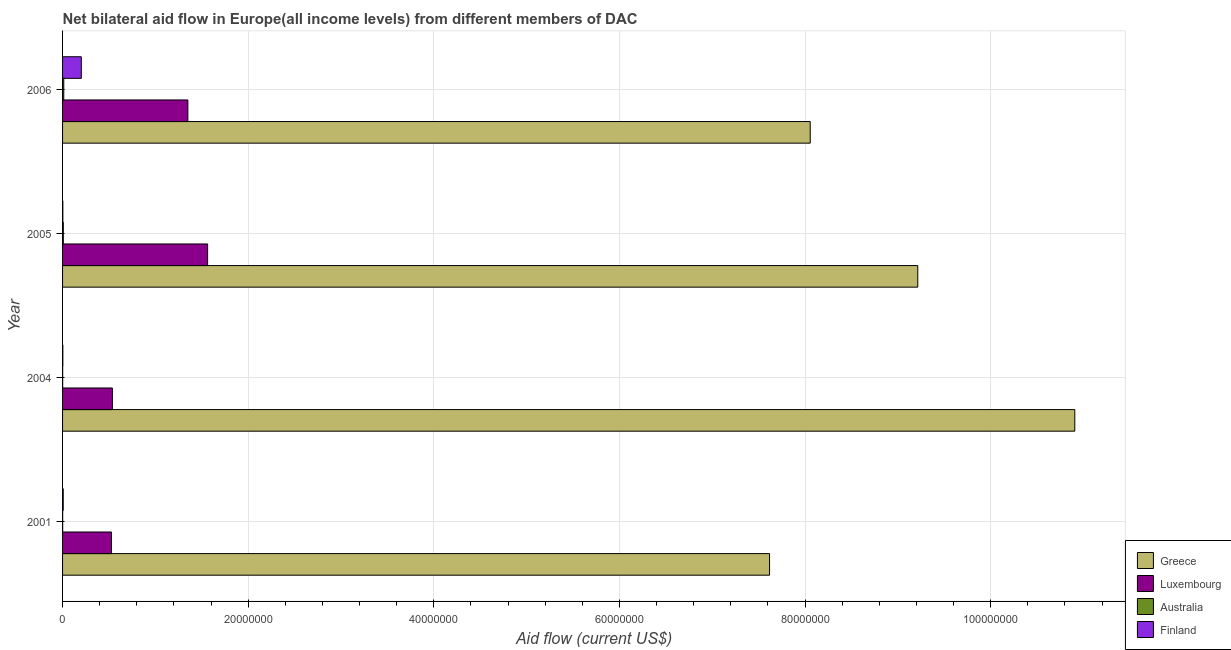How many different coloured bars are there?
Your answer should be very brief. 4. Are the number of bars per tick equal to the number of legend labels?
Your response must be concise. Yes. How many bars are there on the 3rd tick from the top?
Your answer should be compact. 4. How many bars are there on the 3rd tick from the bottom?
Make the answer very short. 4. What is the label of the 3rd group of bars from the top?
Make the answer very short. 2004. What is the amount of aid given by luxembourg in 2005?
Provide a succinct answer. 1.56e+07. Across all years, what is the maximum amount of aid given by greece?
Keep it short and to the point. 1.09e+08. Across all years, what is the minimum amount of aid given by finland?
Ensure brevity in your answer.  3.00e+04. What is the total amount of aid given by luxembourg in the graph?
Provide a succinct answer. 3.98e+07. What is the difference between the amount of aid given by greece in 2001 and that in 2005?
Give a very brief answer. -1.60e+07. What is the difference between the amount of aid given by australia in 2005 and the amount of aid given by luxembourg in 2006?
Ensure brevity in your answer.  -1.34e+07. What is the average amount of aid given by australia per year?
Offer a very short reply. 5.75e+04. In the year 2006, what is the difference between the amount of aid given by greece and amount of aid given by luxembourg?
Your answer should be compact. 6.71e+07. In how many years, is the amount of aid given by australia greater than 68000000 US$?
Provide a short and direct response. 0. What is the ratio of the amount of aid given by australia in 2004 to that in 2006?
Your response must be concise. 0.08. What is the difference between the highest and the second highest amount of aid given by finland?
Your answer should be very brief. 1.95e+06. What is the difference between the highest and the lowest amount of aid given by finland?
Offer a terse response. 1.99e+06. Is the sum of the amount of aid given by australia in 2001 and 2004 greater than the maximum amount of aid given by greece across all years?
Make the answer very short. No. Is it the case that in every year, the sum of the amount of aid given by finland and amount of aid given by australia is greater than the sum of amount of aid given by greece and amount of aid given by luxembourg?
Make the answer very short. No. What does the 1st bar from the top in 2005 represents?
Your response must be concise. Finland. What does the 4th bar from the bottom in 2005 represents?
Make the answer very short. Finland. Is it the case that in every year, the sum of the amount of aid given by greece and amount of aid given by luxembourg is greater than the amount of aid given by australia?
Provide a short and direct response. Yes. How many years are there in the graph?
Offer a terse response. 4. Are the values on the major ticks of X-axis written in scientific E-notation?
Keep it short and to the point. No. Does the graph contain any zero values?
Your response must be concise. No. How many legend labels are there?
Keep it short and to the point. 4. How are the legend labels stacked?
Your response must be concise. Vertical. What is the title of the graph?
Provide a succinct answer. Net bilateral aid flow in Europe(all income levels) from different members of DAC. What is the label or title of the X-axis?
Offer a terse response. Aid flow (current US$). What is the label or title of the Y-axis?
Offer a terse response. Year. What is the Aid flow (current US$) of Greece in 2001?
Offer a terse response. 7.62e+07. What is the Aid flow (current US$) of Luxembourg in 2001?
Your answer should be compact. 5.27e+06. What is the Aid flow (current US$) in Finland in 2001?
Provide a succinct answer. 7.00e+04. What is the Aid flow (current US$) of Greece in 2004?
Make the answer very short. 1.09e+08. What is the Aid flow (current US$) of Luxembourg in 2004?
Keep it short and to the point. 5.37e+06. What is the Aid flow (current US$) of Finland in 2004?
Offer a very short reply. 3.00e+04. What is the Aid flow (current US$) in Greece in 2005?
Your answer should be compact. 9.22e+07. What is the Aid flow (current US$) of Luxembourg in 2005?
Keep it short and to the point. 1.56e+07. What is the Aid flow (current US$) of Australia in 2005?
Your answer should be very brief. 8.00e+04. What is the Aid flow (current US$) in Finland in 2005?
Offer a terse response. 3.00e+04. What is the Aid flow (current US$) of Greece in 2006?
Your response must be concise. 8.06e+07. What is the Aid flow (current US$) of Luxembourg in 2006?
Offer a very short reply. 1.35e+07. What is the Aid flow (current US$) in Finland in 2006?
Offer a terse response. 2.02e+06. Across all years, what is the maximum Aid flow (current US$) in Greece?
Give a very brief answer. 1.09e+08. Across all years, what is the maximum Aid flow (current US$) of Luxembourg?
Make the answer very short. 1.56e+07. Across all years, what is the maximum Aid flow (current US$) in Australia?
Give a very brief answer. 1.30e+05. Across all years, what is the maximum Aid flow (current US$) in Finland?
Provide a short and direct response. 2.02e+06. Across all years, what is the minimum Aid flow (current US$) of Greece?
Offer a terse response. 7.62e+07. Across all years, what is the minimum Aid flow (current US$) of Luxembourg?
Provide a short and direct response. 5.27e+06. What is the total Aid flow (current US$) in Greece in the graph?
Your answer should be compact. 3.58e+08. What is the total Aid flow (current US$) of Luxembourg in the graph?
Your answer should be compact. 3.98e+07. What is the total Aid flow (current US$) of Australia in the graph?
Give a very brief answer. 2.30e+05. What is the total Aid flow (current US$) of Finland in the graph?
Provide a short and direct response. 2.15e+06. What is the difference between the Aid flow (current US$) in Greece in 2001 and that in 2004?
Keep it short and to the point. -3.29e+07. What is the difference between the Aid flow (current US$) in Luxembourg in 2001 and that in 2004?
Provide a short and direct response. -1.00e+05. What is the difference between the Aid flow (current US$) in Finland in 2001 and that in 2004?
Provide a succinct answer. 4.00e+04. What is the difference between the Aid flow (current US$) in Greece in 2001 and that in 2005?
Your answer should be very brief. -1.60e+07. What is the difference between the Aid flow (current US$) of Luxembourg in 2001 and that in 2005?
Offer a terse response. -1.04e+07. What is the difference between the Aid flow (current US$) in Australia in 2001 and that in 2005?
Keep it short and to the point. -7.00e+04. What is the difference between the Aid flow (current US$) in Finland in 2001 and that in 2005?
Your answer should be very brief. 4.00e+04. What is the difference between the Aid flow (current US$) in Greece in 2001 and that in 2006?
Offer a very short reply. -4.38e+06. What is the difference between the Aid flow (current US$) of Luxembourg in 2001 and that in 2006?
Give a very brief answer. -8.23e+06. What is the difference between the Aid flow (current US$) of Australia in 2001 and that in 2006?
Offer a very short reply. -1.20e+05. What is the difference between the Aid flow (current US$) in Finland in 2001 and that in 2006?
Keep it short and to the point. -1.95e+06. What is the difference between the Aid flow (current US$) of Greece in 2004 and that in 2005?
Offer a terse response. 1.69e+07. What is the difference between the Aid flow (current US$) in Luxembourg in 2004 and that in 2005?
Ensure brevity in your answer.  -1.03e+07. What is the difference between the Aid flow (current US$) of Australia in 2004 and that in 2005?
Offer a very short reply. -7.00e+04. What is the difference between the Aid flow (current US$) of Greece in 2004 and that in 2006?
Your answer should be compact. 2.85e+07. What is the difference between the Aid flow (current US$) of Luxembourg in 2004 and that in 2006?
Keep it short and to the point. -8.13e+06. What is the difference between the Aid flow (current US$) of Australia in 2004 and that in 2006?
Give a very brief answer. -1.20e+05. What is the difference between the Aid flow (current US$) of Finland in 2004 and that in 2006?
Provide a succinct answer. -1.99e+06. What is the difference between the Aid flow (current US$) of Greece in 2005 and that in 2006?
Your answer should be compact. 1.16e+07. What is the difference between the Aid flow (current US$) of Luxembourg in 2005 and that in 2006?
Keep it short and to the point. 2.13e+06. What is the difference between the Aid flow (current US$) of Australia in 2005 and that in 2006?
Offer a terse response. -5.00e+04. What is the difference between the Aid flow (current US$) in Finland in 2005 and that in 2006?
Give a very brief answer. -1.99e+06. What is the difference between the Aid flow (current US$) of Greece in 2001 and the Aid flow (current US$) of Luxembourg in 2004?
Give a very brief answer. 7.08e+07. What is the difference between the Aid flow (current US$) of Greece in 2001 and the Aid flow (current US$) of Australia in 2004?
Ensure brevity in your answer.  7.62e+07. What is the difference between the Aid flow (current US$) in Greece in 2001 and the Aid flow (current US$) in Finland in 2004?
Your answer should be compact. 7.62e+07. What is the difference between the Aid flow (current US$) in Luxembourg in 2001 and the Aid flow (current US$) in Australia in 2004?
Your response must be concise. 5.26e+06. What is the difference between the Aid flow (current US$) of Luxembourg in 2001 and the Aid flow (current US$) of Finland in 2004?
Offer a terse response. 5.24e+06. What is the difference between the Aid flow (current US$) in Greece in 2001 and the Aid flow (current US$) in Luxembourg in 2005?
Offer a terse response. 6.06e+07. What is the difference between the Aid flow (current US$) in Greece in 2001 and the Aid flow (current US$) in Australia in 2005?
Offer a terse response. 7.61e+07. What is the difference between the Aid flow (current US$) of Greece in 2001 and the Aid flow (current US$) of Finland in 2005?
Give a very brief answer. 7.62e+07. What is the difference between the Aid flow (current US$) in Luxembourg in 2001 and the Aid flow (current US$) in Australia in 2005?
Your response must be concise. 5.19e+06. What is the difference between the Aid flow (current US$) in Luxembourg in 2001 and the Aid flow (current US$) in Finland in 2005?
Your response must be concise. 5.24e+06. What is the difference between the Aid flow (current US$) of Australia in 2001 and the Aid flow (current US$) of Finland in 2005?
Your answer should be compact. -2.00e+04. What is the difference between the Aid flow (current US$) of Greece in 2001 and the Aid flow (current US$) of Luxembourg in 2006?
Your answer should be compact. 6.27e+07. What is the difference between the Aid flow (current US$) in Greece in 2001 and the Aid flow (current US$) in Australia in 2006?
Provide a short and direct response. 7.60e+07. What is the difference between the Aid flow (current US$) in Greece in 2001 and the Aid flow (current US$) in Finland in 2006?
Your response must be concise. 7.42e+07. What is the difference between the Aid flow (current US$) of Luxembourg in 2001 and the Aid flow (current US$) of Australia in 2006?
Your response must be concise. 5.14e+06. What is the difference between the Aid flow (current US$) of Luxembourg in 2001 and the Aid flow (current US$) of Finland in 2006?
Your response must be concise. 3.25e+06. What is the difference between the Aid flow (current US$) of Australia in 2001 and the Aid flow (current US$) of Finland in 2006?
Make the answer very short. -2.01e+06. What is the difference between the Aid flow (current US$) in Greece in 2004 and the Aid flow (current US$) in Luxembourg in 2005?
Your answer should be very brief. 9.34e+07. What is the difference between the Aid flow (current US$) in Greece in 2004 and the Aid flow (current US$) in Australia in 2005?
Provide a short and direct response. 1.09e+08. What is the difference between the Aid flow (current US$) in Greece in 2004 and the Aid flow (current US$) in Finland in 2005?
Make the answer very short. 1.09e+08. What is the difference between the Aid flow (current US$) of Luxembourg in 2004 and the Aid flow (current US$) of Australia in 2005?
Give a very brief answer. 5.29e+06. What is the difference between the Aid flow (current US$) of Luxembourg in 2004 and the Aid flow (current US$) of Finland in 2005?
Offer a very short reply. 5.34e+06. What is the difference between the Aid flow (current US$) in Australia in 2004 and the Aid flow (current US$) in Finland in 2005?
Your answer should be compact. -2.00e+04. What is the difference between the Aid flow (current US$) in Greece in 2004 and the Aid flow (current US$) in Luxembourg in 2006?
Your answer should be very brief. 9.56e+07. What is the difference between the Aid flow (current US$) in Greece in 2004 and the Aid flow (current US$) in Australia in 2006?
Your answer should be very brief. 1.09e+08. What is the difference between the Aid flow (current US$) in Greece in 2004 and the Aid flow (current US$) in Finland in 2006?
Keep it short and to the point. 1.07e+08. What is the difference between the Aid flow (current US$) in Luxembourg in 2004 and the Aid flow (current US$) in Australia in 2006?
Provide a short and direct response. 5.24e+06. What is the difference between the Aid flow (current US$) of Luxembourg in 2004 and the Aid flow (current US$) of Finland in 2006?
Offer a very short reply. 3.35e+06. What is the difference between the Aid flow (current US$) of Australia in 2004 and the Aid flow (current US$) of Finland in 2006?
Provide a short and direct response. -2.01e+06. What is the difference between the Aid flow (current US$) in Greece in 2005 and the Aid flow (current US$) in Luxembourg in 2006?
Give a very brief answer. 7.86e+07. What is the difference between the Aid flow (current US$) of Greece in 2005 and the Aid flow (current US$) of Australia in 2006?
Ensure brevity in your answer.  9.20e+07. What is the difference between the Aid flow (current US$) in Greece in 2005 and the Aid flow (current US$) in Finland in 2006?
Provide a short and direct response. 9.01e+07. What is the difference between the Aid flow (current US$) of Luxembourg in 2005 and the Aid flow (current US$) of Australia in 2006?
Make the answer very short. 1.55e+07. What is the difference between the Aid flow (current US$) of Luxembourg in 2005 and the Aid flow (current US$) of Finland in 2006?
Your answer should be very brief. 1.36e+07. What is the difference between the Aid flow (current US$) of Australia in 2005 and the Aid flow (current US$) of Finland in 2006?
Provide a succinct answer. -1.94e+06. What is the average Aid flow (current US$) of Greece per year?
Keep it short and to the point. 8.95e+07. What is the average Aid flow (current US$) of Luxembourg per year?
Your answer should be compact. 9.94e+06. What is the average Aid flow (current US$) of Australia per year?
Keep it short and to the point. 5.75e+04. What is the average Aid flow (current US$) in Finland per year?
Keep it short and to the point. 5.38e+05. In the year 2001, what is the difference between the Aid flow (current US$) in Greece and Aid flow (current US$) in Luxembourg?
Ensure brevity in your answer.  7.09e+07. In the year 2001, what is the difference between the Aid flow (current US$) in Greece and Aid flow (current US$) in Australia?
Keep it short and to the point. 7.62e+07. In the year 2001, what is the difference between the Aid flow (current US$) in Greece and Aid flow (current US$) in Finland?
Ensure brevity in your answer.  7.61e+07. In the year 2001, what is the difference between the Aid flow (current US$) of Luxembourg and Aid flow (current US$) of Australia?
Your answer should be very brief. 5.26e+06. In the year 2001, what is the difference between the Aid flow (current US$) in Luxembourg and Aid flow (current US$) in Finland?
Keep it short and to the point. 5.20e+06. In the year 2004, what is the difference between the Aid flow (current US$) in Greece and Aid flow (current US$) in Luxembourg?
Offer a terse response. 1.04e+08. In the year 2004, what is the difference between the Aid flow (current US$) of Greece and Aid flow (current US$) of Australia?
Your answer should be very brief. 1.09e+08. In the year 2004, what is the difference between the Aid flow (current US$) of Greece and Aid flow (current US$) of Finland?
Your response must be concise. 1.09e+08. In the year 2004, what is the difference between the Aid flow (current US$) of Luxembourg and Aid flow (current US$) of Australia?
Ensure brevity in your answer.  5.36e+06. In the year 2004, what is the difference between the Aid flow (current US$) in Luxembourg and Aid flow (current US$) in Finland?
Your answer should be very brief. 5.34e+06. In the year 2005, what is the difference between the Aid flow (current US$) of Greece and Aid flow (current US$) of Luxembourg?
Ensure brevity in your answer.  7.65e+07. In the year 2005, what is the difference between the Aid flow (current US$) in Greece and Aid flow (current US$) in Australia?
Provide a short and direct response. 9.21e+07. In the year 2005, what is the difference between the Aid flow (current US$) of Greece and Aid flow (current US$) of Finland?
Provide a short and direct response. 9.21e+07. In the year 2005, what is the difference between the Aid flow (current US$) of Luxembourg and Aid flow (current US$) of Australia?
Provide a succinct answer. 1.56e+07. In the year 2005, what is the difference between the Aid flow (current US$) of Luxembourg and Aid flow (current US$) of Finland?
Provide a short and direct response. 1.56e+07. In the year 2006, what is the difference between the Aid flow (current US$) in Greece and Aid flow (current US$) in Luxembourg?
Your response must be concise. 6.71e+07. In the year 2006, what is the difference between the Aid flow (current US$) in Greece and Aid flow (current US$) in Australia?
Offer a very short reply. 8.04e+07. In the year 2006, what is the difference between the Aid flow (current US$) in Greece and Aid flow (current US$) in Finland?
Keep it short and to the point. 7.85e+07. In the year 2006, what is the difference between the Aid flow (current US$) in Luxembourg and Aid flow (current US$) in Australia?
Offer a terse response. 1.34e+07. In the year 2006, what is the difference between the Aid flow (current US$) in Luxembourg and Aid flow (current US$) in Finland?
Your response must be concise. 1.15e+07. In the year 2006, what is the difference between the Aid flow (current US$) of Australia and Aid flow (current US$) of Finland?
Give a very brief answer. -1.89e+06. What is the ratio of the Aid flow (current US$) of Greece in 2001 to that in 2004?
Your answer should be very brief. 0.7. What is the ratio of the Aid flow (current US$) of Luxembourg in 2001 to that in 2004?
Offer a terse response. 0.98. What is the ratio of the Aid flow (current US$) in Australia in 2001 to that in 2004?
Offer a very short reply. 1. What is the ratio of the Aid flow (current US$) of Finland in 2001 to that in 2004?
Keep it short and to the point. 2.33. What is the ratio of the Aid flow (current US$) in Greece in 2001 to that in 2005?
Provide a succinct answer. 0.83. What is the ratio of the Aid flow (current US$) in Luxembourg in 2001 to that in 2005?
Make the answer very short. 0.34. What is the ratio of the Aid flow (current US$) in Australia in 2001 to that in 2005?
Offer a very short reply. 0.12. What is the ratio of the Aid flow (current US$) in Finland in 2001 to that in 2005?
Offer a terse response. 2.33. What is the ratio of the Aid flow (current US$) of Greece in 2001 to that in 2006?
Your answer should be compact. 0.95. What is the ratio of the Aid flow (current US$) of Luxembourg in 2001 to that in 2006?
Ensure brevity in your answer.  0.39. What is the ratio of the Aid flow (current US$) of Australia in 2001 to that in 2006?
Offer a terse response. 0.08. What is the ratio of the Aid flow (current US$) in Finland in 2001 to that in 2006?
Ensure brevity in your answer.  0.03. What is the ratio of the Aid flow (current US$) in Greece in 2004 to that in 2005?
Your answer should be compact. 1.18. What is the ratio of the Aid flow (current US$) of Luxembourg in 2004 to that in 2005?
Offer a terse response. 0.34. What is the ratio of the Aid flow (current US$) of Greece in 2004 to that in 2006?
Offer a very short reply. 1.35. What is the ratio of the Aid flow (current US$) of Luxembourg in 2004 to that in 2006?
Provide a short and direct response. 0.4. What is the ratio of the Aid flow (current US$) in Australia in 2004 to that in 2006?
Provide a short and direct response. 0.08. What is the ratio of the Aid flow (current US$) of Finland in 2004 to that in 2006?
Keep it short and to the point. 0.01. What is the ratio of the Aid flow (current US$) in Greece in 2005 to that in 2006?
Your response must be concise. 1.14. What is the ratio of the Aid flow (current US$) in Luxembourg in 2005 to that in 2006?
Your response must be concise. 1.16. What is the ratio of the Aid flow (current US$) in Australia in 2005 to that in 2006?
Make the answer very short. 0.62. What is the ratio of the Aid flow (current US$) of Finland in 2005 to that in 2006?
Provide a short and direct response. 0.01. What is the difference between the highest and the second highest Aid flow (current US$) in Greece?
Keep it short and to the point. 1.69e+07. What is the difference between the highest and the second highest Aid flow (current US$) of Luxembourg?
Give a very brief answer. 2.13e+06. What is the difference between the highest and the second highest Aid flow (current US$) of Finland?
Provide a short and direct response. 1.95e+06. What is the difference between the highest and the lowest Aid flow (current US$) in Greece?
Make the answer very short. 3.29e+07. What is the difference between the highest and the lowest Aid flow (current US$) in Luxembourg?
Keep it short and to the point. 1.04e+07. What is the difference between the highest and the lowest Aid flow (current US$) in Australia?
Offer a terse response. 1.20e+05. What is the difference between the highest and the lowest Aid flow (current US$) in Finland?
Make the answer very short. 1.99e+06. 